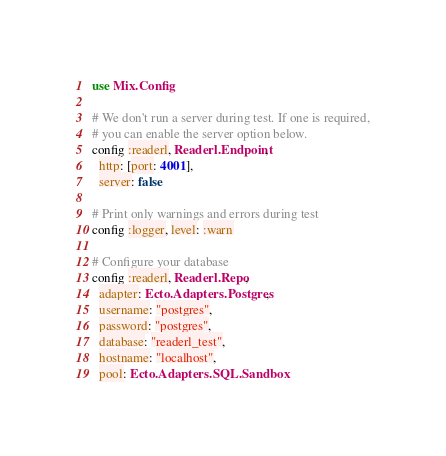Convert code to text. <code><loc_0><loc_0><loc_500><loc_500><_Elixir_>use Mix.Config

# We don't run a server during test. If one is required,
# you can enable the server option below.
config :readerl, Readerl.Endpoint,
  http: [port: 4001],
  server: false

# Print only warnings and errors during test
config :logger, level: :warn

# Configure your database
config :readerl, Readerl.Repo,
  adapter: Ecto.Adapters.Postgres,
  username: "postgres",
  password: "postgres",
  database: "readerl_test",
  hostname: "localhost",
  pool: Ecto.Adapters.SQL.Sandbox
</code> 